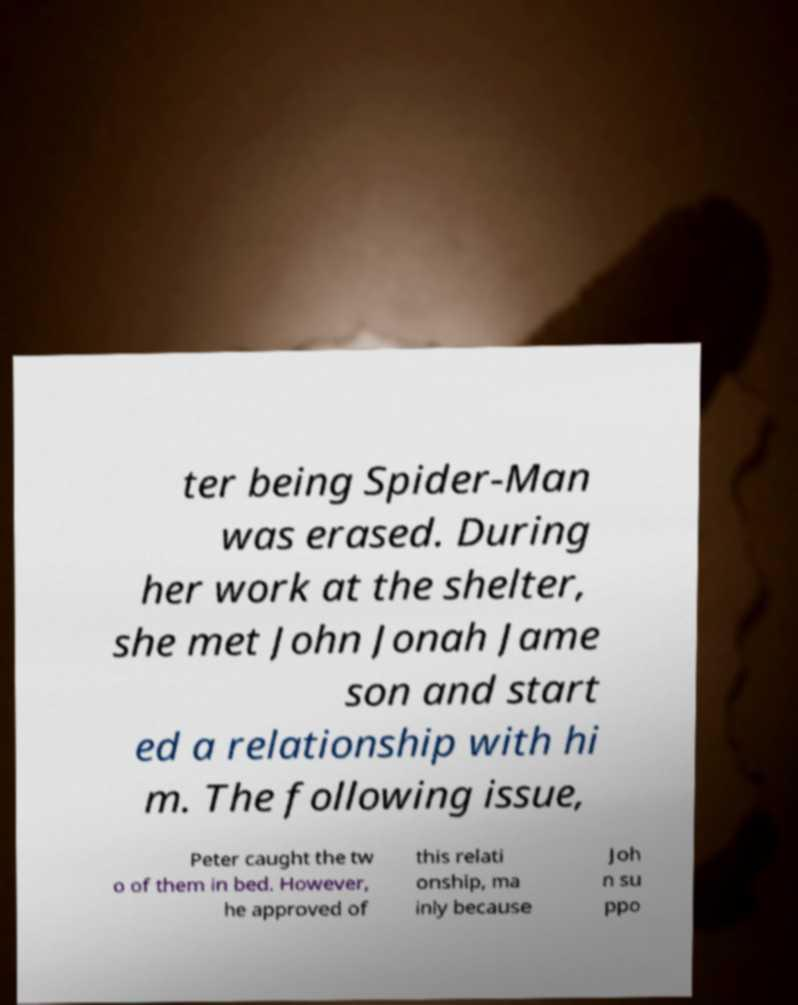For documentation purposes, I need the text within this image transcribed. Could you provide that? ter being Spider-Man was erased. During her work at the shelter, she met John Jonah Jame son and start ed a relationship with hi m. The following issue, Peter caught the tw o of them in bed. However, he approved of this relati onship, ma inly because Joh n su ppo 